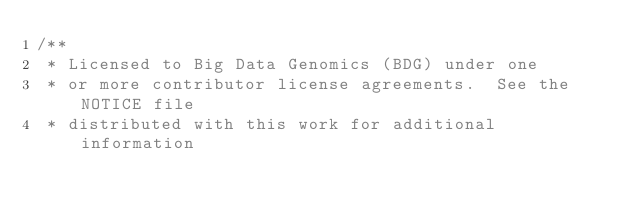Convert code to text. <code><loc_0><loc_0><loc_500><loc_500><_Scala_>/**
 * Licensed to Big Data Genomics (BDG) under one
 * or more contributor license agreements.  See the NOTICE file
 * distributed with this work for additional information</code> 